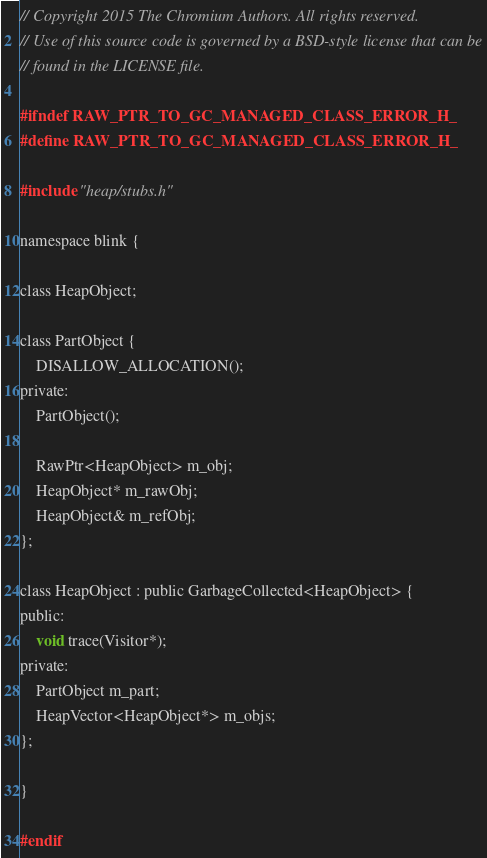<code> <loc_0><loc_0><loc_500><loc_500><_C_>// Copyright 2015 The Chromium Authors. All rights reserved.
// Use of this source code is governed by a BSD-style license that can be
// found in the LICENSE file.

#ifndef RAW_PTR_TO_GC_MANAGED_CLASS_ERROR_H_
#define RAW_PTR_TO_GC_MANAGED_CLASS_ERROR_H_

#include "heap/stubs.h"

namespace blink {

class HeapObject;

class PartObject {
    DISALLOW_ALLOCATION();
private:
    PartObject();

    RawPtr<HeapObject> m_obj;
    HeapObject* m_rawObj;
    HeapObject& m_refObj;
};

class HeapObject : public GarbageCollected<HeapObject> {
public:
    void trace(Visitor*);
private:
    PartObject m_part;
    HeapVector<HeapObject*> m_objs;
};

}

#endif
</code> 